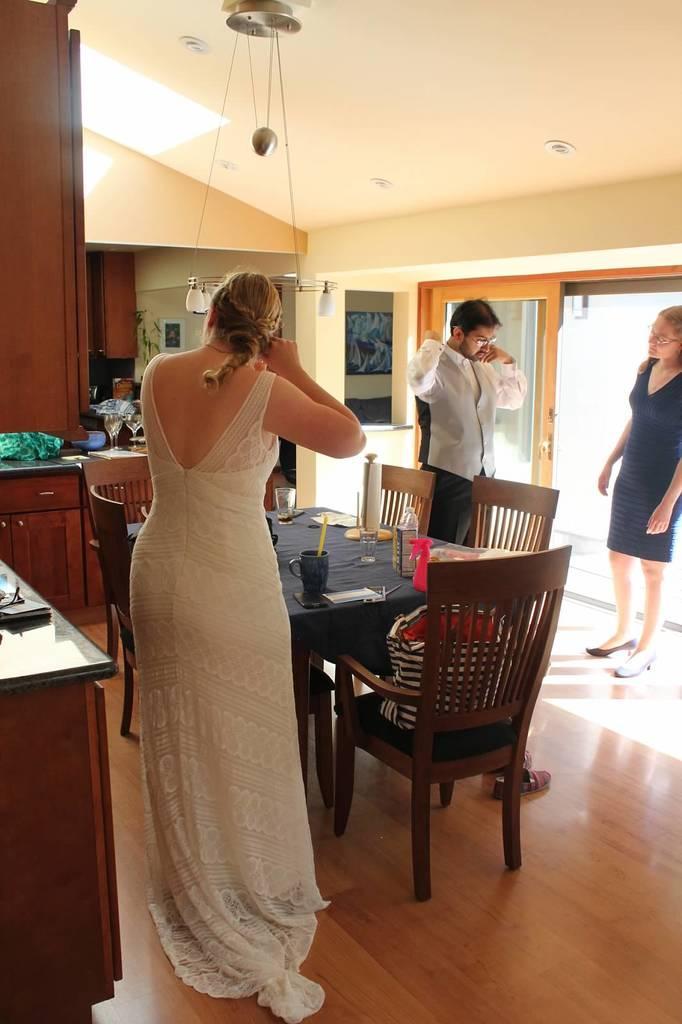In one or two sentences, can you explain what this image depicts? In this picture there is a woman standing and there is a person standing over here 